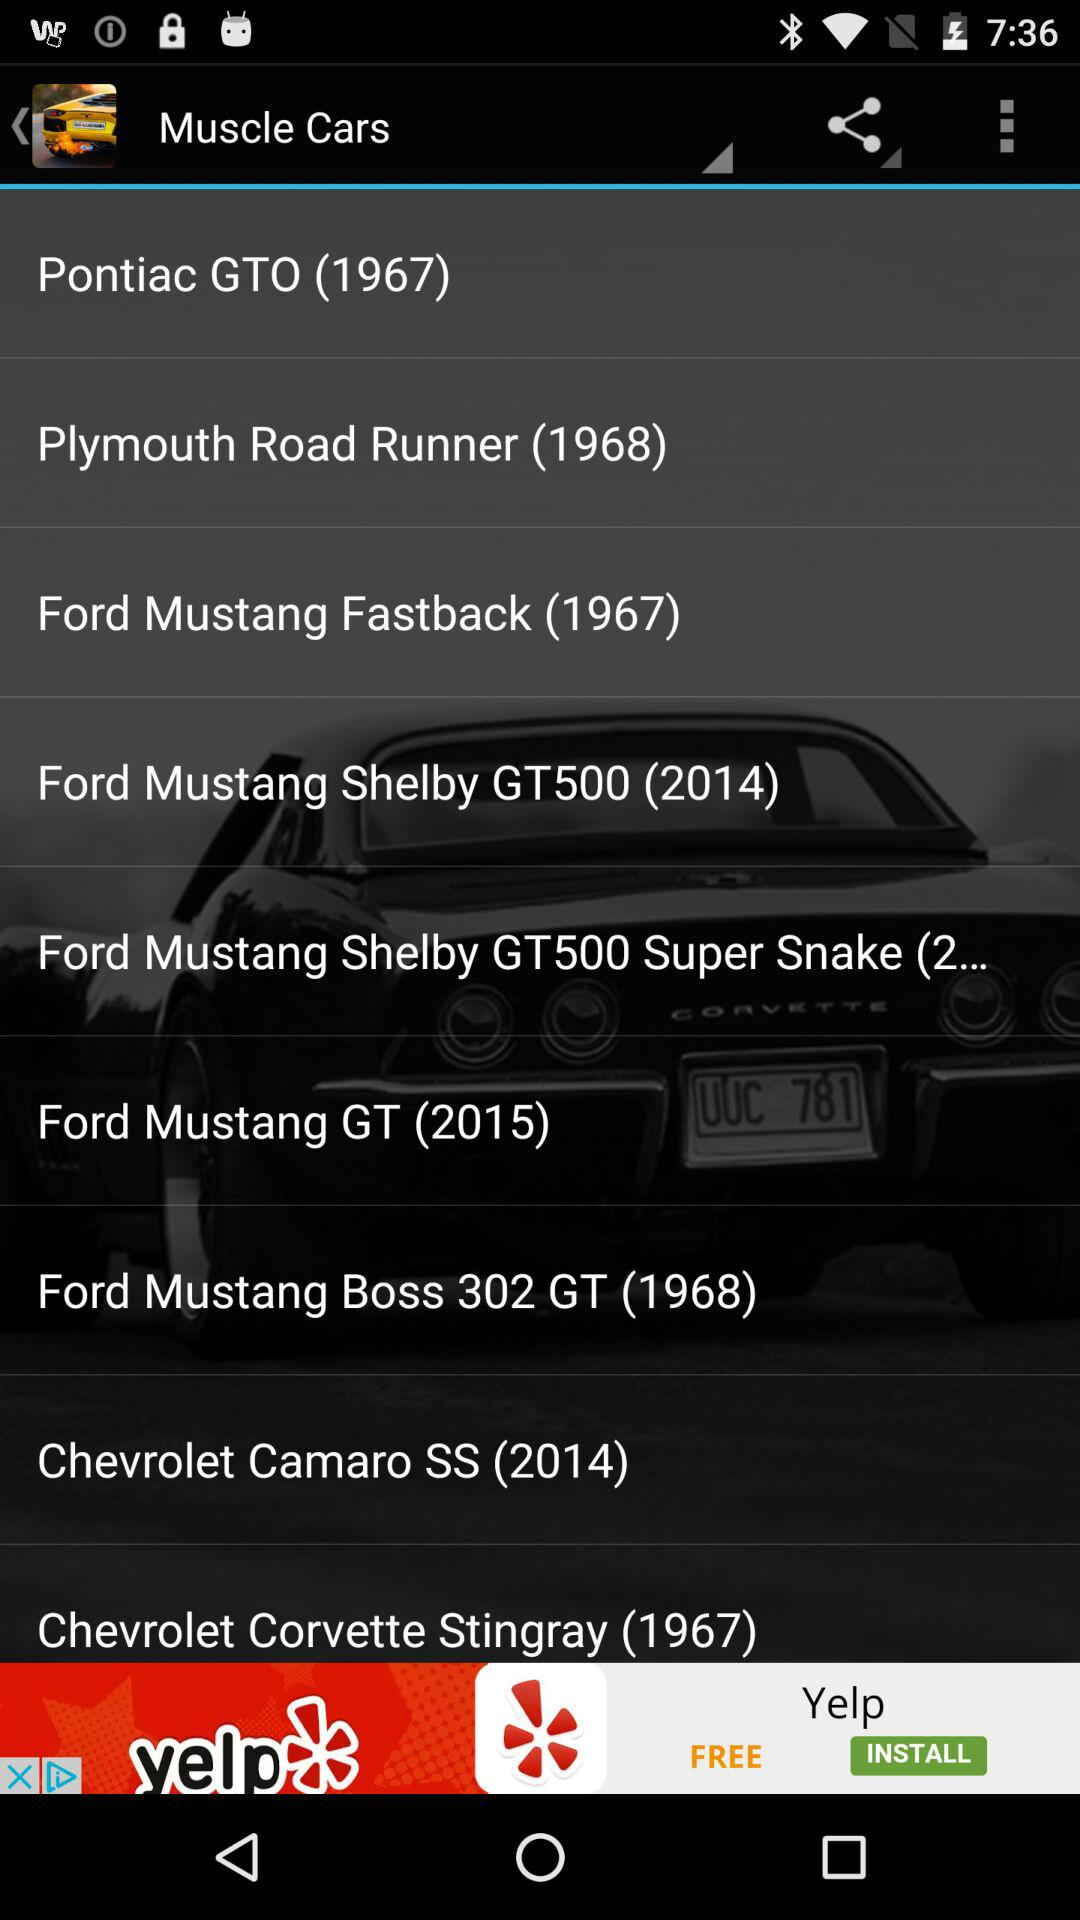How many cars are from the 2010s?
Answer the question using a single word or phrase. 3 